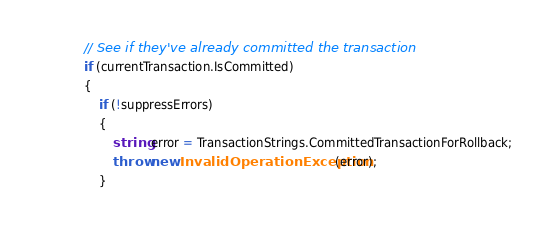<code> <loc_0><loc_0><loc_500><loc_500><_C#_>
            // See if they've already committed the transaction
            if (currentTransaction.IsCommitted)
            {
                if (!suppressErrors)
                {
                    string error = TransactionStrings.CommittedTransactionForRollback;
                    throw new InvalidOperationException(error);
                }</code> 